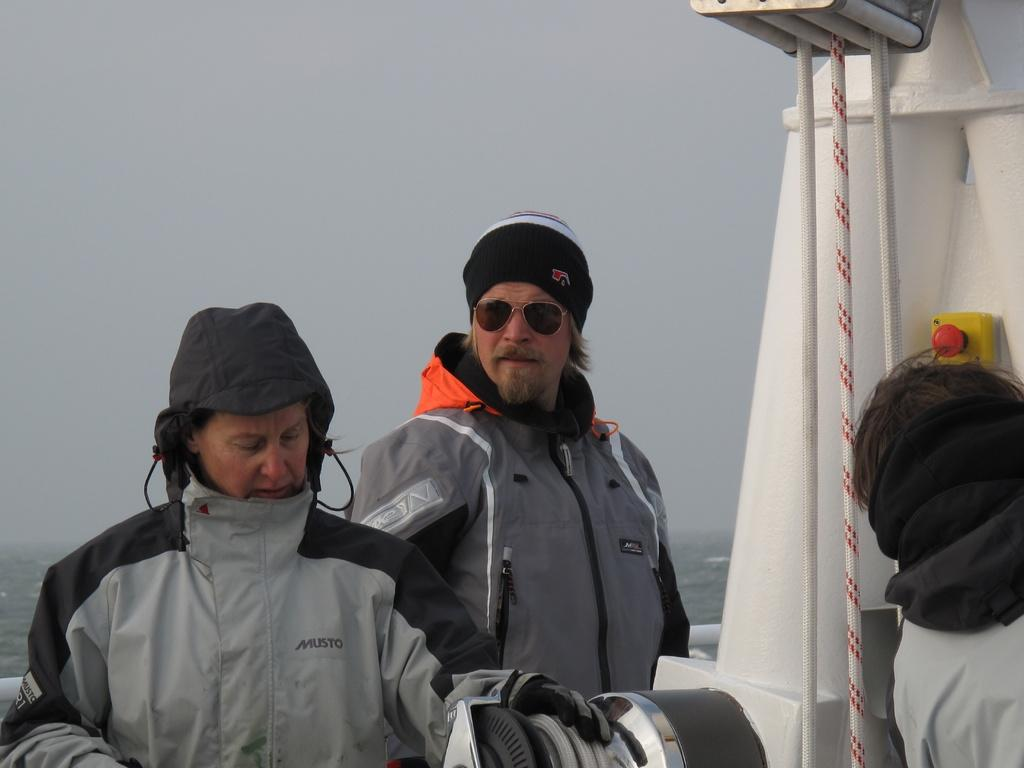How many people are in the boat in the image? There are three members in the boat. Can you describe one of the members in the boat? One of the members is wearing spectacles. What can be seen in the background of the image? There is a sky visible in the background of the image. How many apples are being held by the person wearing spectacles in the image? There are no apples visible in the image; the person wearing spectacles is in a boat with two other members. 